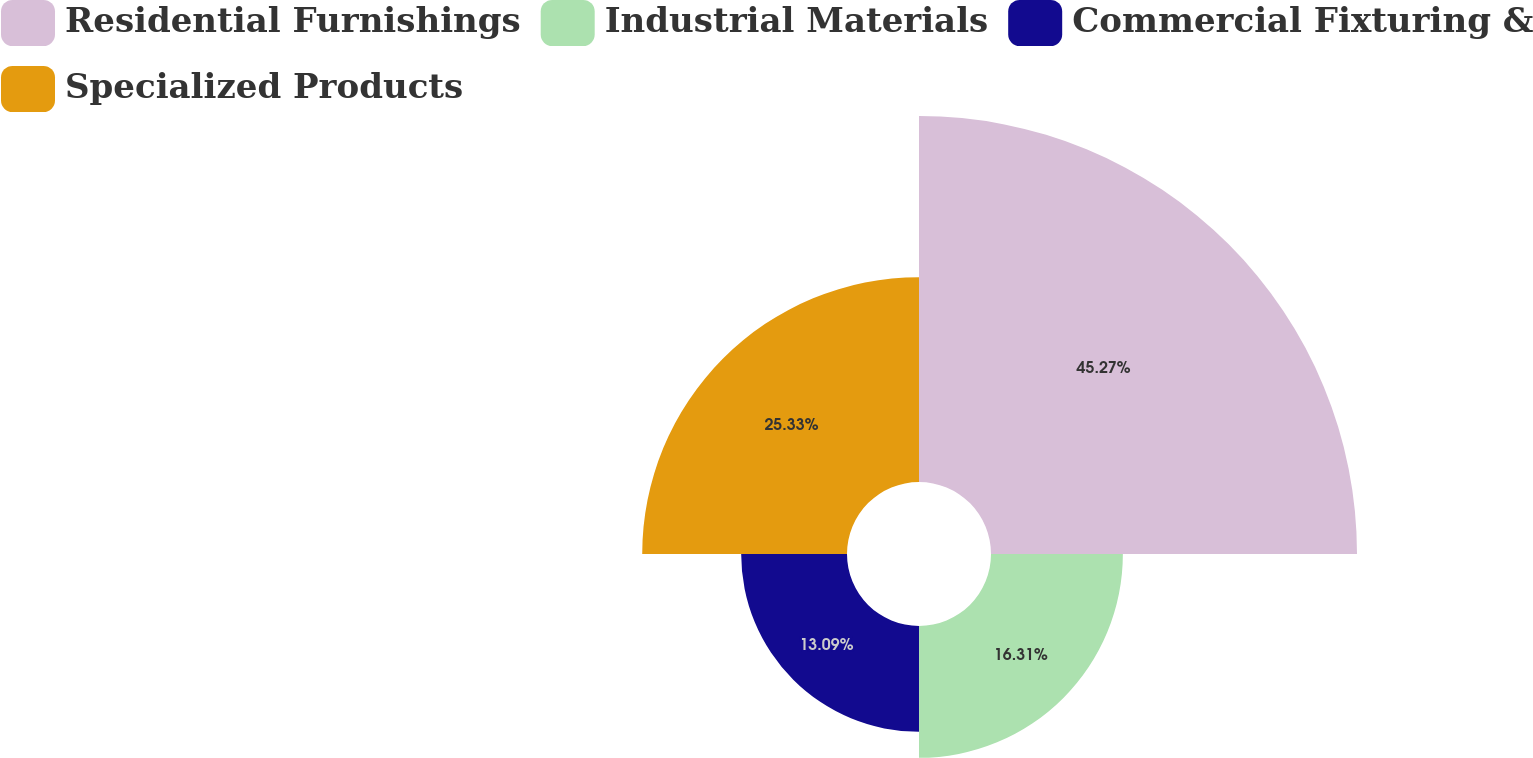Convert chart. <chart><loc_0><loc_0><loc_500><loc_500><pie_chart><fcel>Residential Furnishings<fcel>Industrial Materials<fcel>Commercial Fixturing &<fcel>Specialized Products<nl><fcel>45.27%<fcel>16.31%<fcel>13.09%<fcel>25.33%<nl></chart> 